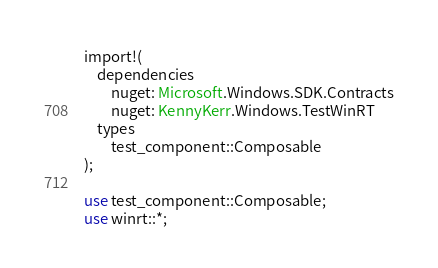<code> <loc_0><loc_0><loc_500><loc_500><_Rust_>import!(
    dependencies
        nuget: Microsoft.Windows.SDK.Contracts
        nuget: KennyKerr.Windows.TestWinRT
    types
        test_component::Composable
);

use test_component::Composable;
use winrt::*;
</code> 